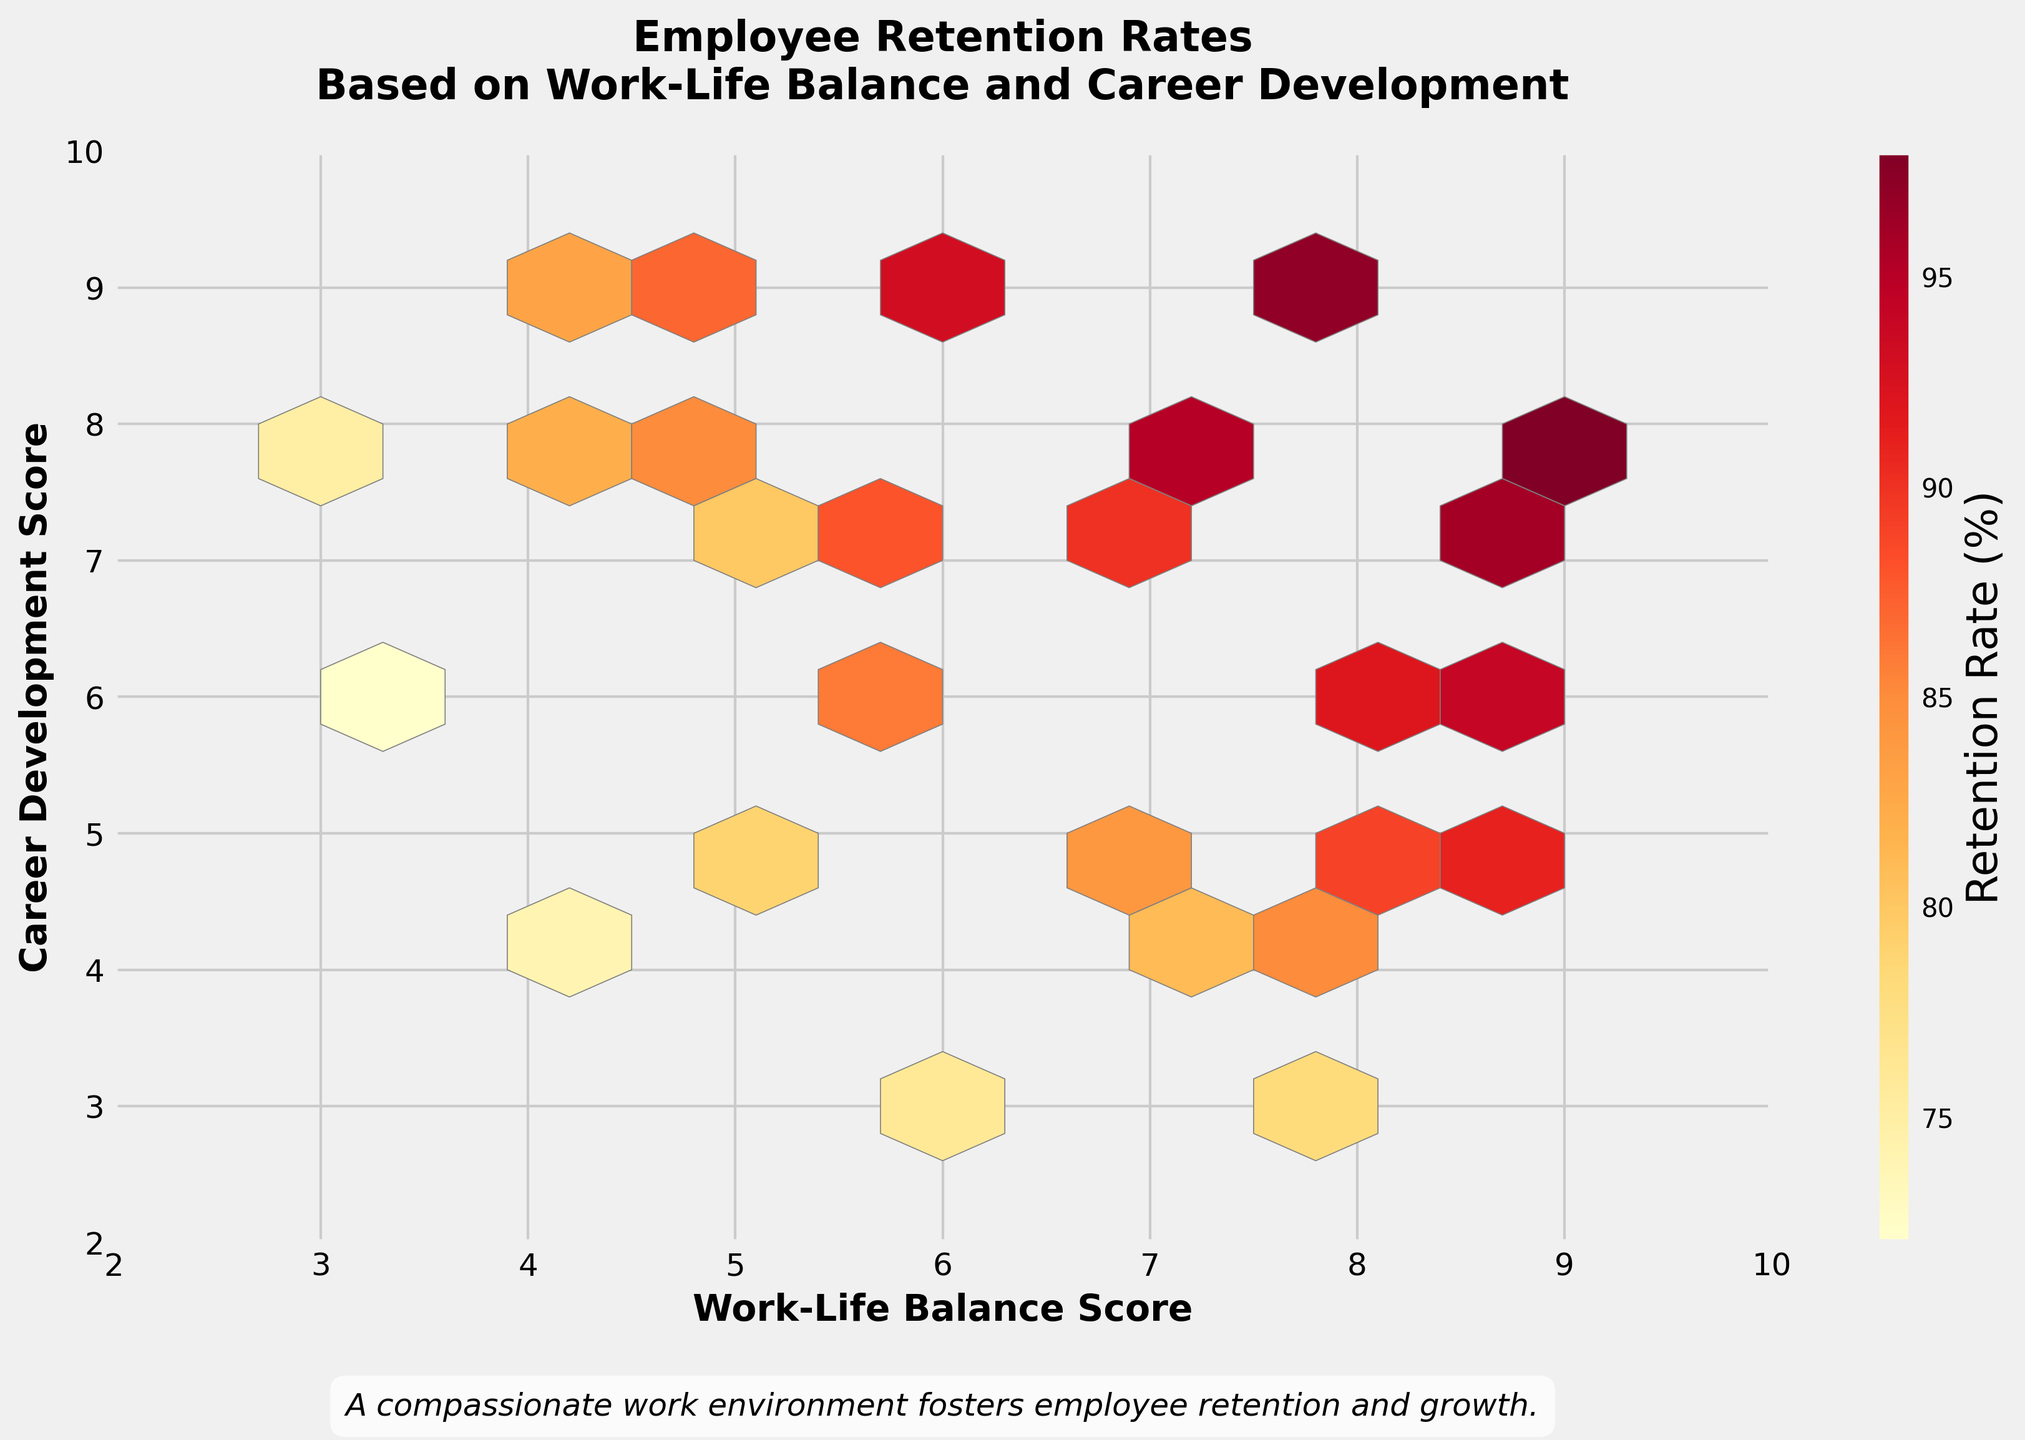What is the title of the hexbin plot? The title is usually displayed at the top of the plot. In this case, the title is written in bold and large font.
Answer: Employee Retention Rates Based on Work-Life Balance and Career Development What are the labels of the x-axis and y-axis? The labels are shown along the x-axis and the y-axis to describe what each axis represents. For the x-axis, it is "Work-Life Balance Score", and for the y-axis, it is "Career Development Score".
Answer: Work-Life Balance Score and Career Development Score What does the color bar on the right represent? In a hexbin plot, the color bar represents a certain measure that varies across hexagons. Here, the color bar is labeled "Retention Rate (%)".
Answer: Retention Rate (%) Which range of work-life balance scores and career development scores have the highest retention rates according to the color map? The retention rate is indicated by the color intensity in the hexbin plot. The brightest colors (near the top of the color bar) are found where both scores are high, particularly clusters around (8,9) and (9,8).
Answer: Around (8,9) and (9,8) What is the color indicating the lowest retention rate on the hexbin plot? By observing the color gradient of the color bar, the color for the lowest retention rate is at the bottom of the bar, which is a lighter shade compared to others.
Answer: Light Yellow What is the evident trend between work-life balance scores and career development scores on employee retention rates from the plot? The hexbin plot provides a visual indication of trends; areas with higher work-life balance and career development scores tend to show darker shades, representing higher retention rates.
Answer: Higher scores in both areas tend to result in higher retention rates Compare the retention rates for employees with a work-life balance score of 7 and career development score of 8 versus a work-life balance score of 3 and career development score of 8. Which is higher? By comparing the hexagons at (7,8) and (3,8), it is apparent that the darker color at (7,8) indicates a higher retention rate than the lighter spot at (3,8).
Answer: 7 and 8 How does the retention rate change as the work-life balance score increases while career development remains constant at 6? Observing the changes vertically on the plot at constant career development score of 6, as work-life balance scores go up from 3 to 9, colors become darker, indicating the retention rate increases.
Answer: It increases Around what score range does the hexbin plot show the most balanced clustering of retention rates? The clustering can be identified in the plot where hexagons with varying ranges of colors are densely packed. Around the score range of (6 to 8) in both dimensions shows such a balanced clustering.
Answer: Around (6 to 8) Based on the plot, can we infer any significant decline in retention rate when work-life balance or career development is lower than 5? The plot highlights less intense colors or more yellow shades around lower scores (<5), indicating a noticeable drop in retention rates for those regions.
Answer: Yes 